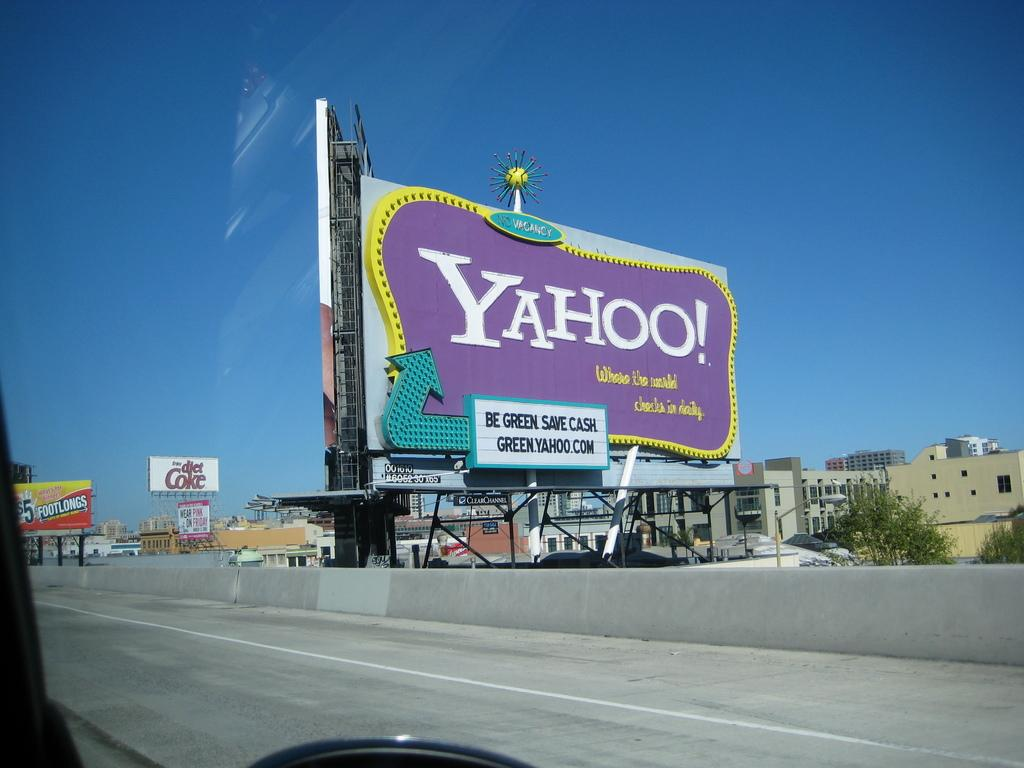<image>
Share a concise interpretation of the image provided. A billboard advertising Yahoo! suggests that you be green and save cash, providing an internet address of green.yahoo.com. 